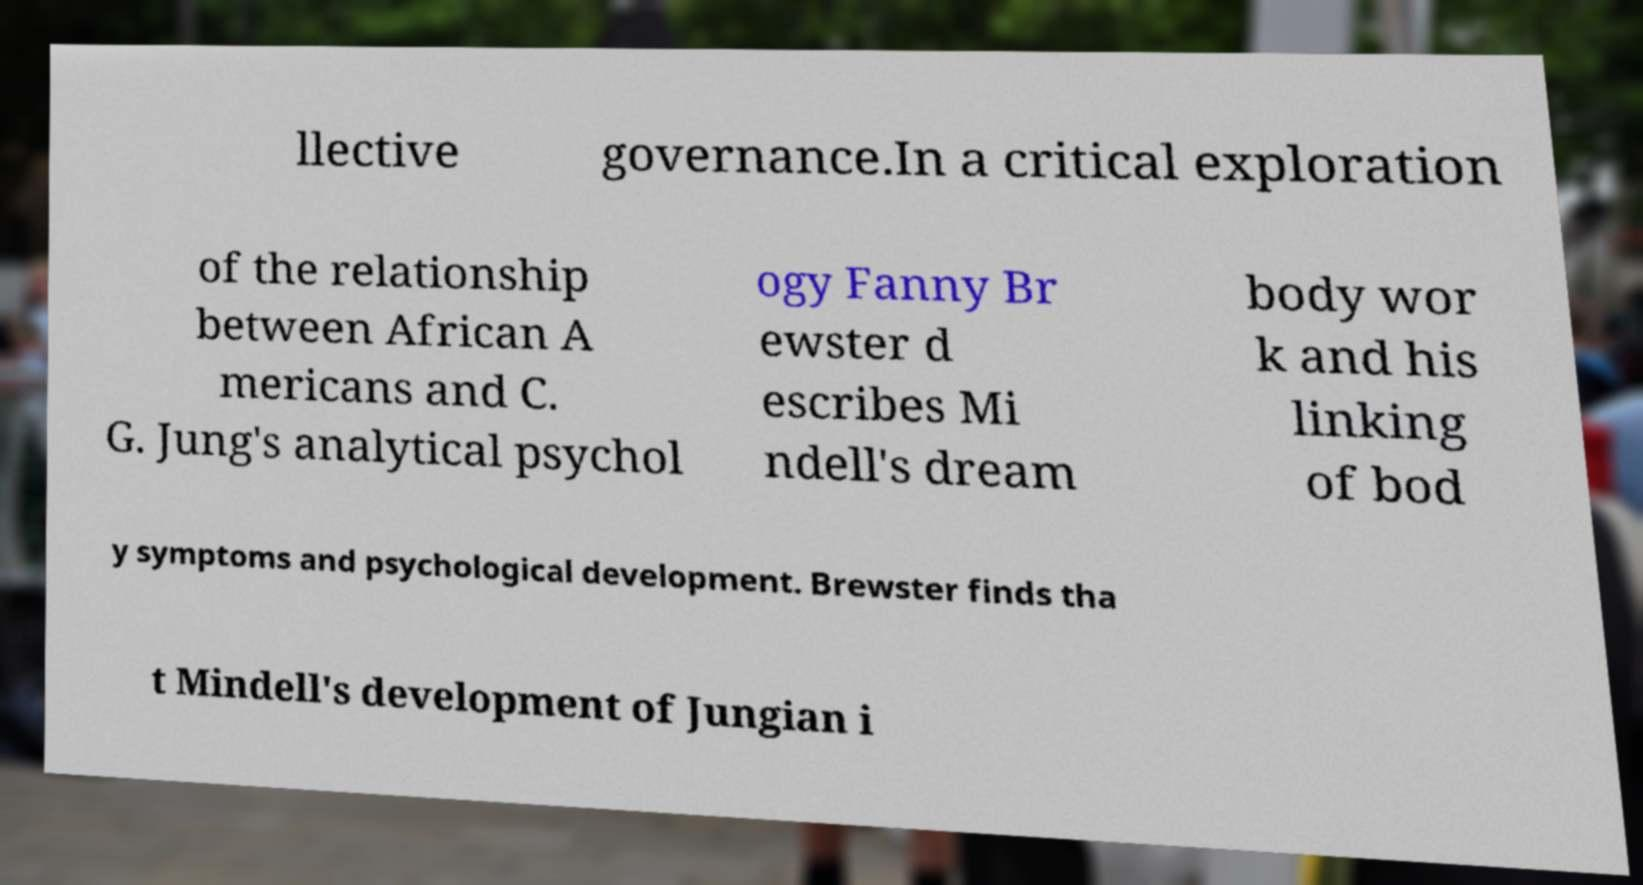There's text embedded in this image that I need extracted. Can you transcribe it verbatim? llective governance.In a critical exploration of the relationship between African A mericans and C. G. Jung's analytical psychol ogy Fanny Br ewster d escribes Mi ndell's dream body wor k and his linking of bod y symptoms and psychological development. Brewster finds tha t Mindell's development of Jungian i 